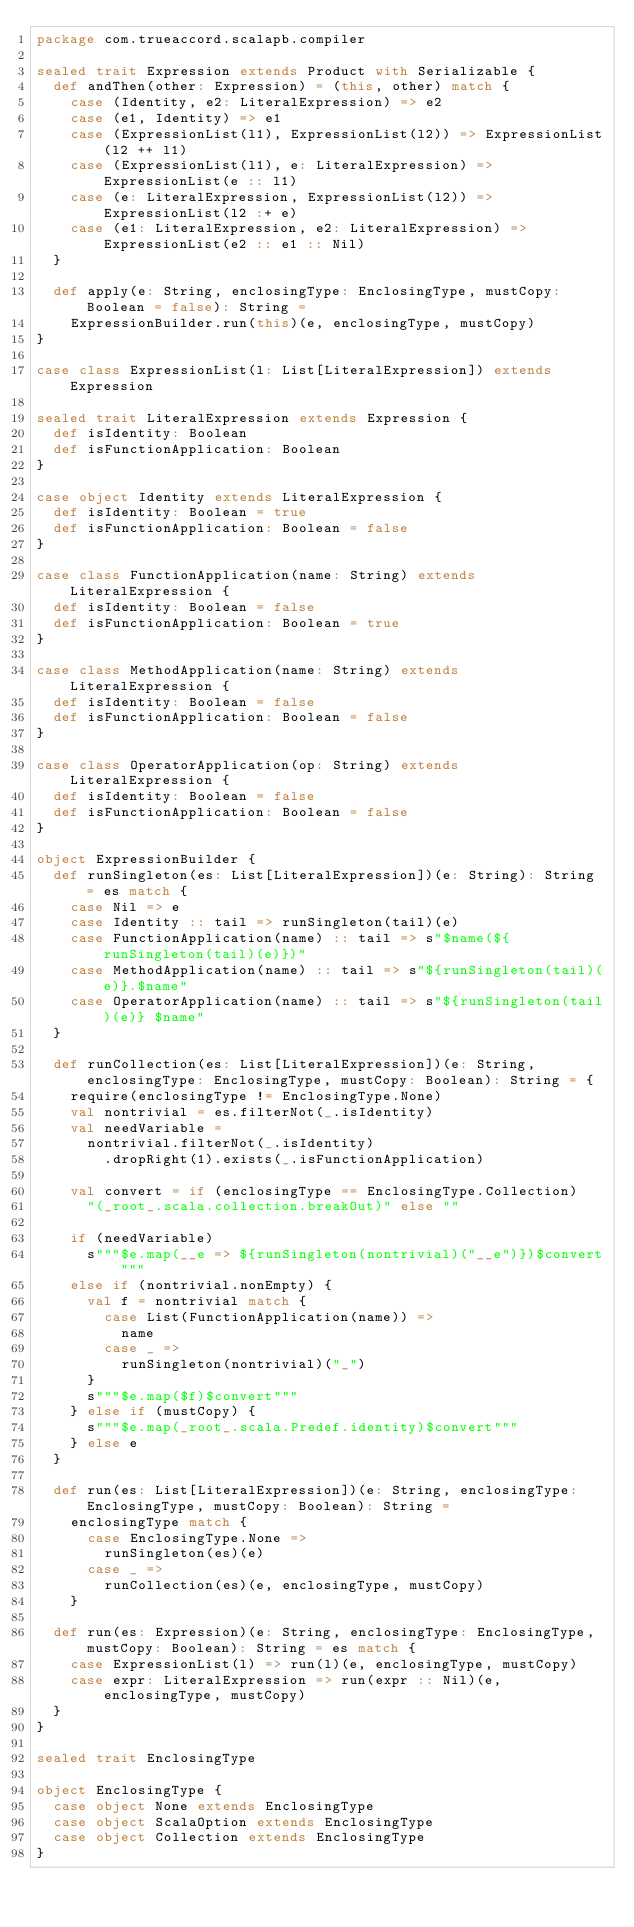Convert code to text. <code><loc_0><loc_0><loc_500><loc_500><_Scala_>package com.trueaccord.scalapb.compiler

sealed trait Expression extends Product with Serializable {
  def andThen(other: Expression) = (this, other) match {
    case (Identity, e2: LiteralExpression) => e2
    case (e1, Identity) => e1
    case (ExpressionList(l1), ExpressionList(l2)) => ExpressionList(l2 ++ l1)
    case (ExpressionList(l1), e: LiteralExpression) => ExpressionList(e :: l1)
    case (e: LiteralExpression, ExpressionList(l2)) => ExpressionList(l2 :+ e)
    case (e1: LiteralExpression, e2: LiteralExpression) => ExpressionList(e2 :: e1 :: Nil)
  }

  def apply(e: String, enclosingType: EnclosingType, mustCopy: Boolean = false): String =
    ExpressionBuilder.run(this)(e, enclosingType, mustCopy)
}

case class ExpressionList(l: List[LiteralExpression]) extends Expression

sealed trait LiteralExpression extends Expression {
  def isIdentity: Boolean
  def isFunctionApplication: Boolean
}

case object Identity extends LiteralExpression {
  def isIdentity: Boolean = true
  def isFunctionApplication: Boolean = false
}

case class FunctionApplication(name: String) extends LiteralExpression {
  def isIdentity: Boolean = false
  def isFunctionApplication: Boolean = true
}

case class MethodApplication(name: String) extends LiteralExpression {
  def isIdentity: Boolean = false
  def isFunctionApplication: Boolean = false
}

case class OperatorApplication(op: String) extends LiteralExpression {
  def isIdentity: Boolean = false
  def isFunctionApplication: Boolean = false
}

object ExpressionBuilder {
  def runSingleton(es: List[LiteralExpression])(e: String): String = es match {
    case Nil => e
    case Identity :: tail => runSingleton(tail)(e)
    case FunctionApplication(name) :: tail => s"$name(${runSingleton(tail)(e)})"
    case MethodApplication(name) :: tail => s"${runSingleton(tail)(e)}.$name"
    case OperatorApplication(name) :: tail => s"${runSingleton(tail)(e)} $name"
  }

  def runCollection(es: List[LiteralExpression])(e: String, enclosingType: EnclosingType, mustCopy: Boolean): String = {
    require(enclosingType != EnclosingType.None)
    val nontrivial = es.filterNot(_.isIdentity)
    val needVariable =
      nontrivial.filterNot(_.isIdentity)
        .dropRight(1).exists(_.isFunctionApplication)

    val convert = if (enclosingType == EnclosingType.Collection)
      "(_root_.scala.collection.breakOut)" else ""

    if (needVariable)
      s"""$e.map(__e => ${runSingleton(nontrivial)("__e")})$convert"""
    else if (nontrivial.nonEmpty) {
      val f = nontrivial match {
        case List(FunctionApplication(name)) =>
          name
        case _ =>
          runSingleton(nontrivial)("_")
      }
      s"""$e.map($f)$convert"""
    } else if (mustCopy) {
      s"""$e.map(_root_.scala.Predef.identity)$convert"""
    } else e
  }

  def run(es: List[LiteralExpression])(e: String, enclosingType: EnclosingType, mustCopy: Boolean): String =
    enclosingType match {
      case EnclosingType.None =>
        runSingleton(es)(e)
      case _ =>
        runCollection(es)(e, enclosingType, mustCopy)
    }

  def run(es: Expression)(e: String, enclosingType: EnclosingType, mustCopy: Boolean): String = es match {
    case ExpressionList(l) => run(l)(e, enclosingType, mustCopy)
    case expr: LiteralExpression => run(expr :: Nil)(e, enclosingType, mustCopy)
  }
}

sealed trait EnclosingType

object EnclosingType {
  case object None extends EnclosingType
  case object ScalaOption extends EnclosingType
  case object Collection extends EnclosingType
}
</code> 